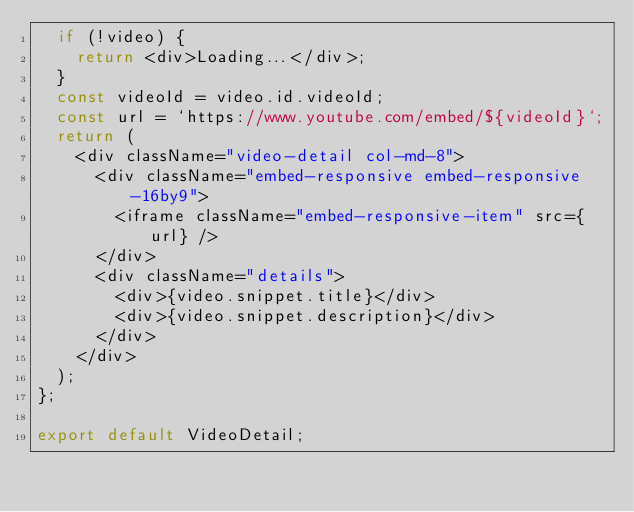<code> <loc_0><loc_0><loc_500><loc_500><_JavaScript_>  if (!video) {
    return <div>Loading...</div>;
  }
  const videoId = video.id.videoId;
  const url = `https://www.youtube.com/embed/${videoId}`;
  return (
    <div className="video-detail col-md-8">
      <div className="embed-responsive embed-responsive-16by9">
        <iframe className="embed-responsive-item" src={url} />
      </div>
      <div className="details">
        <div>{video.snippet.title}</div>
        <div>{video.snippet.description}</div>
      </div>
    </div>
  );
};

export default VideoDetail;
</code> 